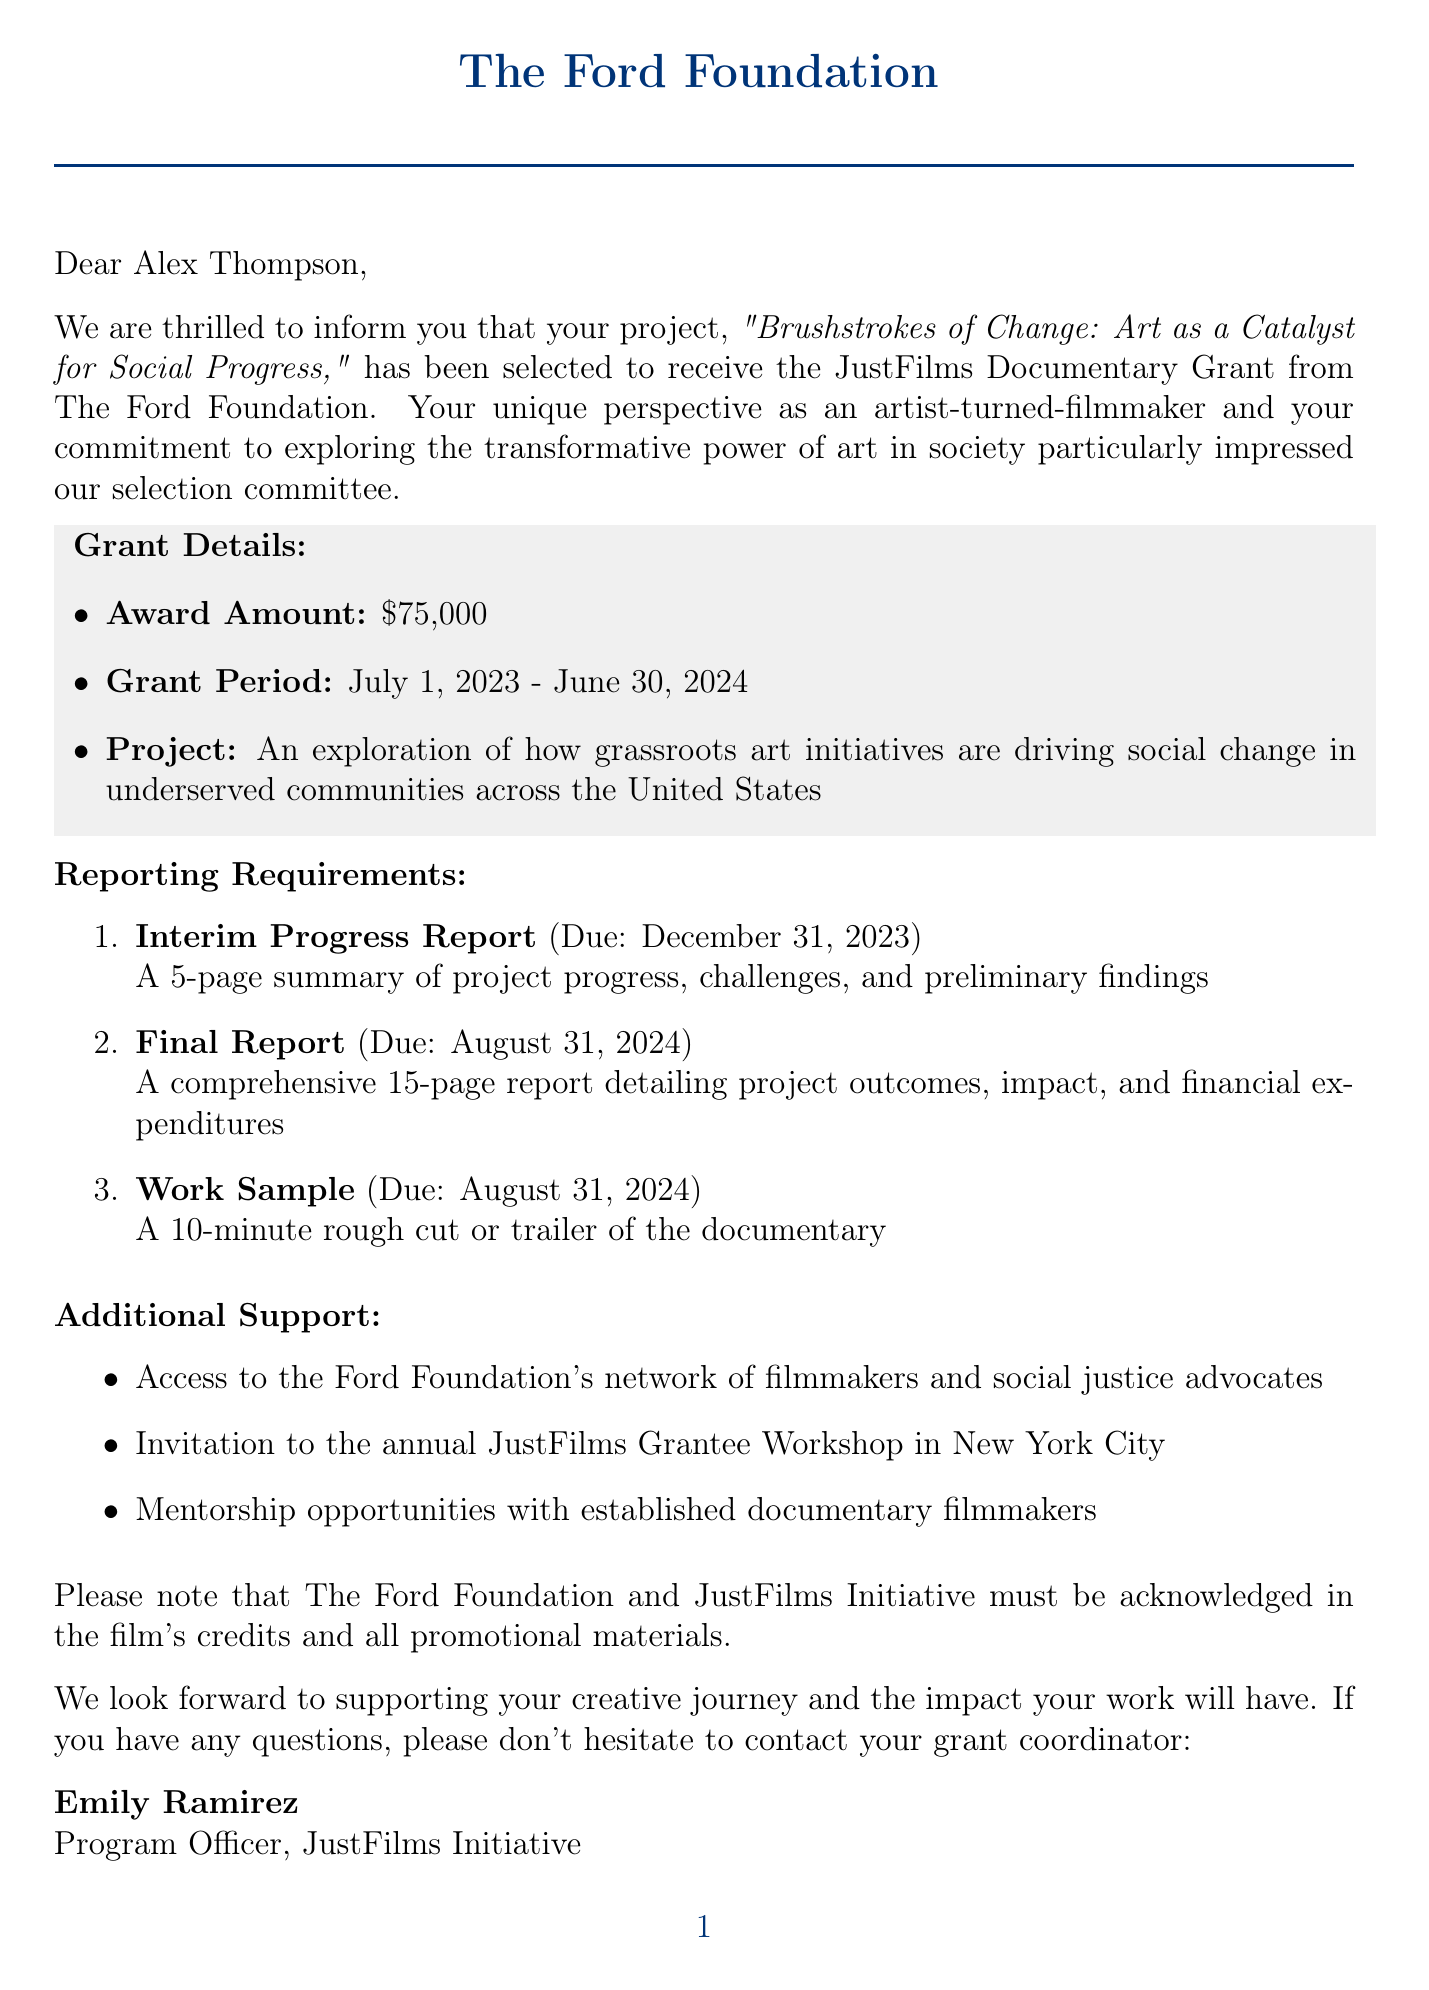What is the award amount? The letter clearly states the award amount granted to the recipient.
Answer: $75,000 Who is the grant coordinator? The letter identifies the individual responsible for coordinating the grant.
Answer: Emily Ramirez What is the project title? The project title is explicitly mentioned in the letter.
Answer: Brushstrokes of Change: Art as a Catalyst for Social Progress When is the final report due? The deadline for the final report is specified in the document.
Answer: August 31, 2024 What percentage of the budget is allocated for production? The letter details the budget allocation, specifying the percentage for production.
Answer: 60% What is one criterion for selection of the grant? The criteria used for selection are listed and elaborated on in the letter.
Answer: Innovative approach to storytelling What must be acknowledged in the film's credits? The requirement regarding acknowledgment in the film's credits is stated in the document.
Answer: The Ford Foundation and JustFilms Initiative How long is the grant period? The document specifies the duration of the grant period.
Answer: July 1, 2023 - June 30, 2024 What type of report is due on December 31, 2023? The letter outlines the types of reports required and their due dates.
Answer: Interim Progress Report 